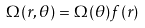<formula> <loc_0><loc_0><loc_500><loc_500>\Omega ( r , \theta ) = \Omega ( \theta ) f ( r )</formula> 